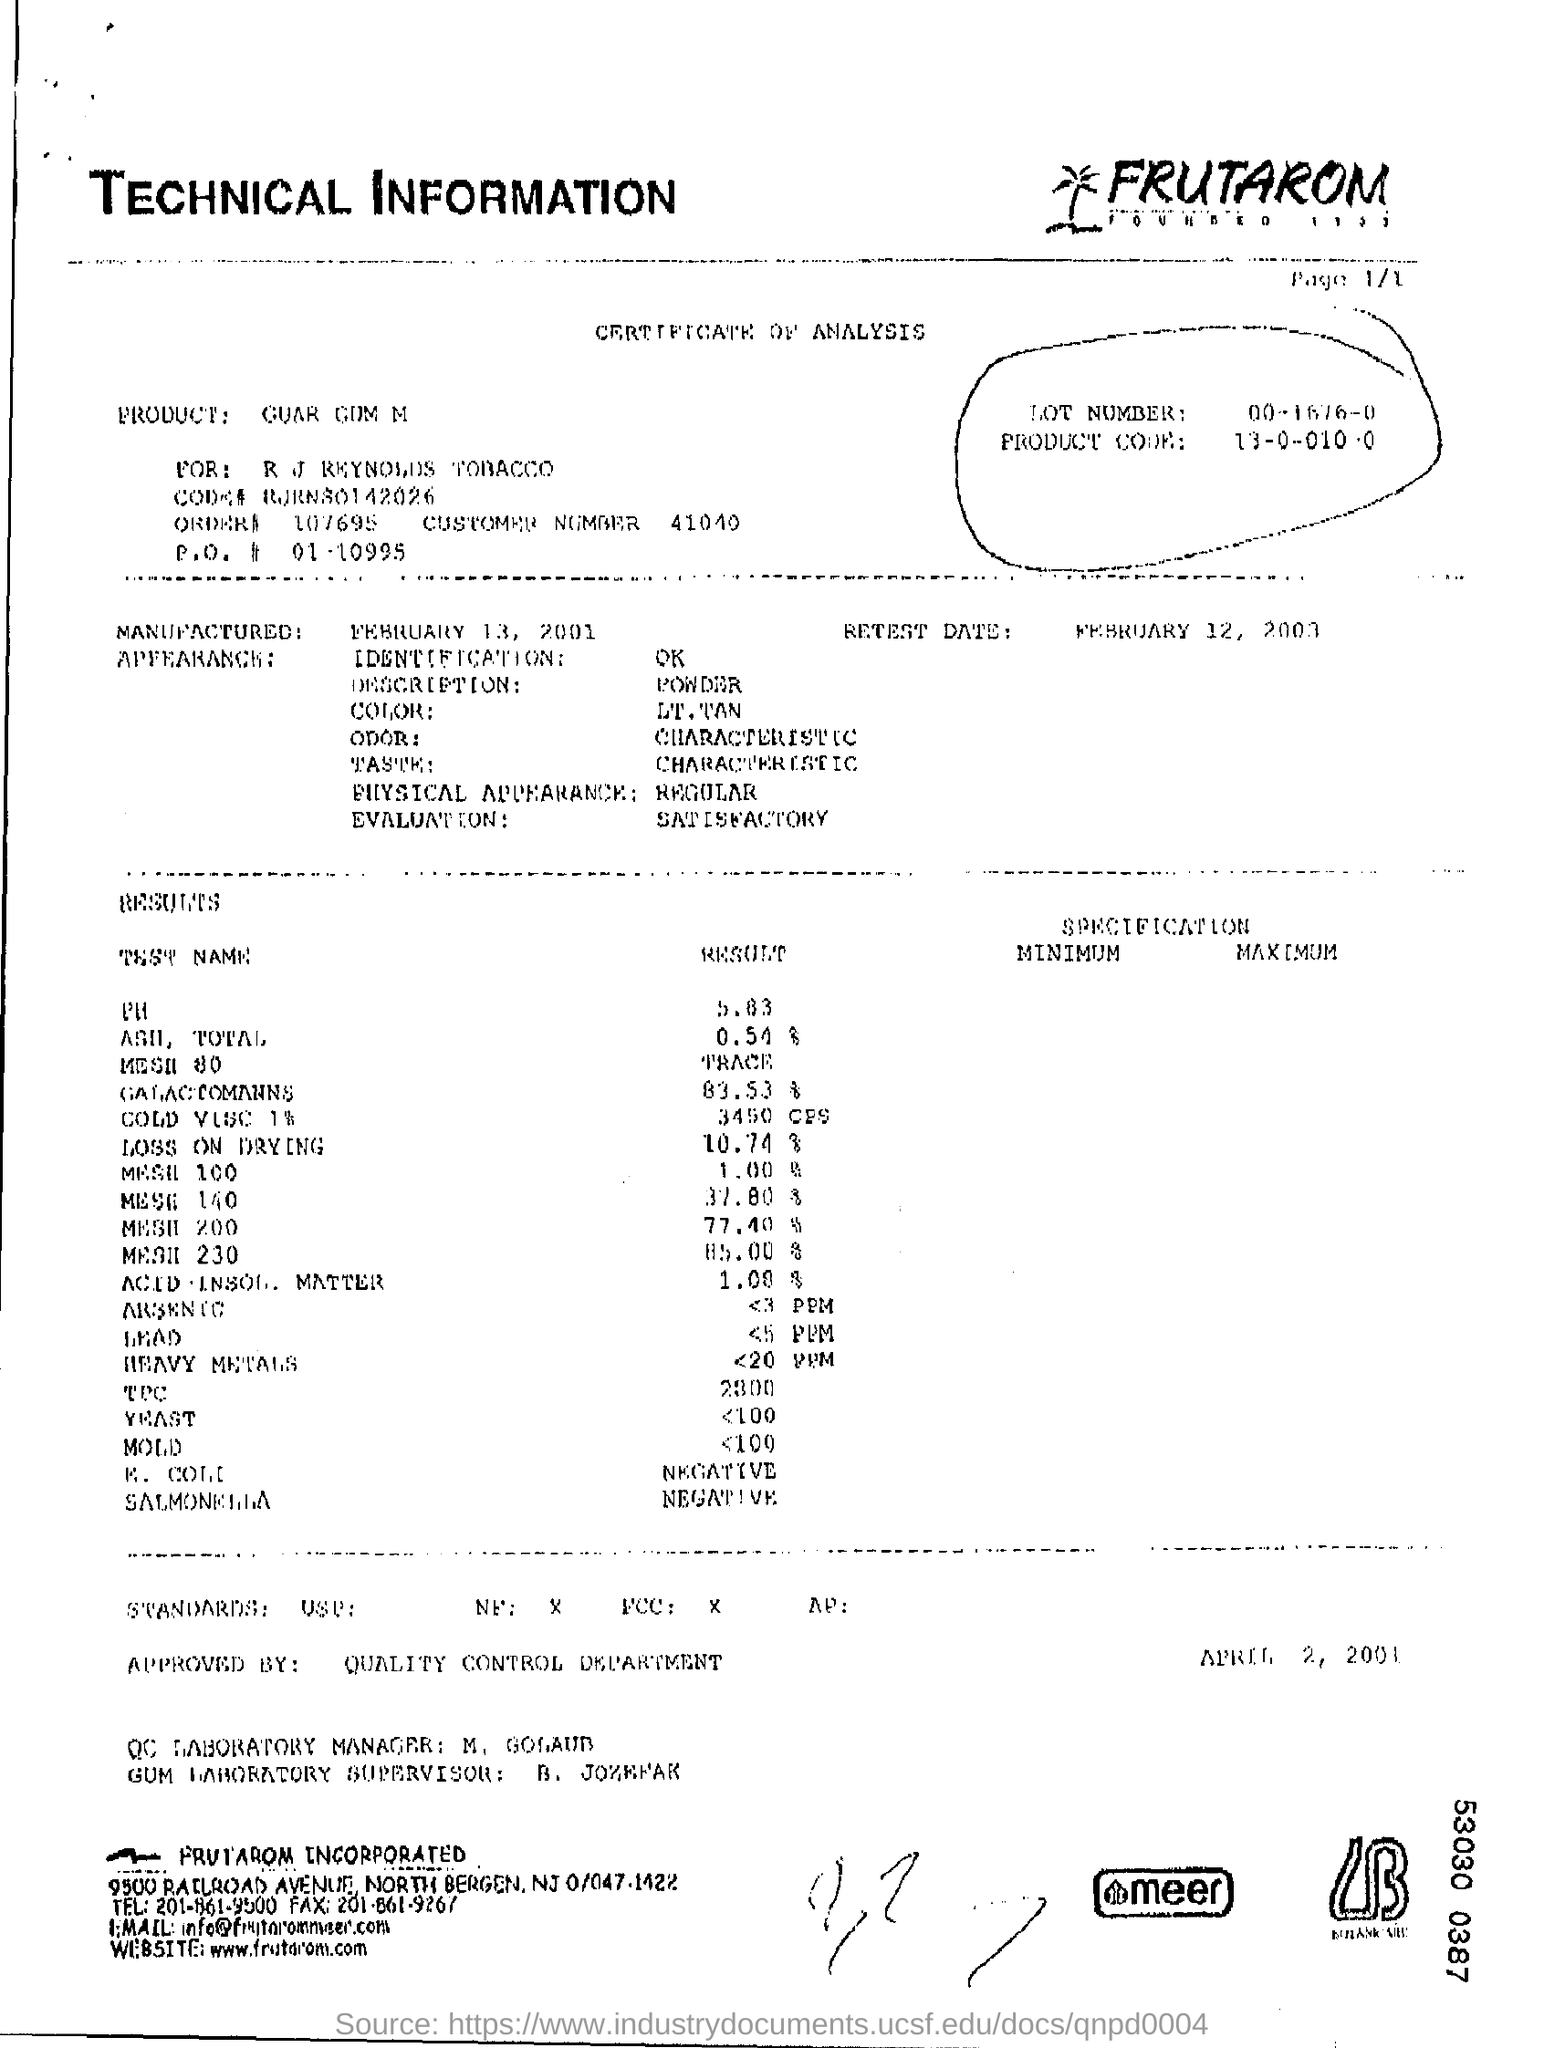Highlight a few significant elements in this photo. The result for PH is 5.83. The color is tan. The description is one of a powder. The physical appearance is regular. The product was manufactured on February 13, 2001. 